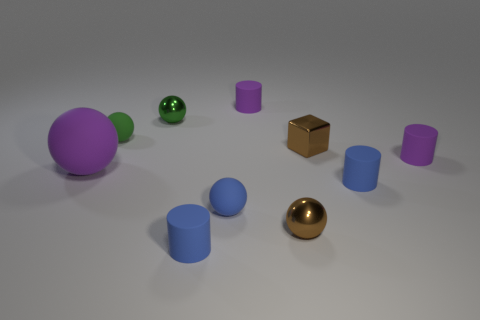Subtract 1 cylinders. How many cylinders are left? 3 Subtract all yellow balls. Subtract all purple cylinders. How many balls are left? 5 Subtract all blocks. How many objects are left? 9 Add 5 tiny brown objects. How many tiny brown objects are left? 7 Add 2 shiny balls. How many shiny balls exist? 4 Subtract 0 yellow cylinders. How many objects are left? 10 Subtract all large objects. Subtract all small green rubber spheres. How many objects are left? 8 